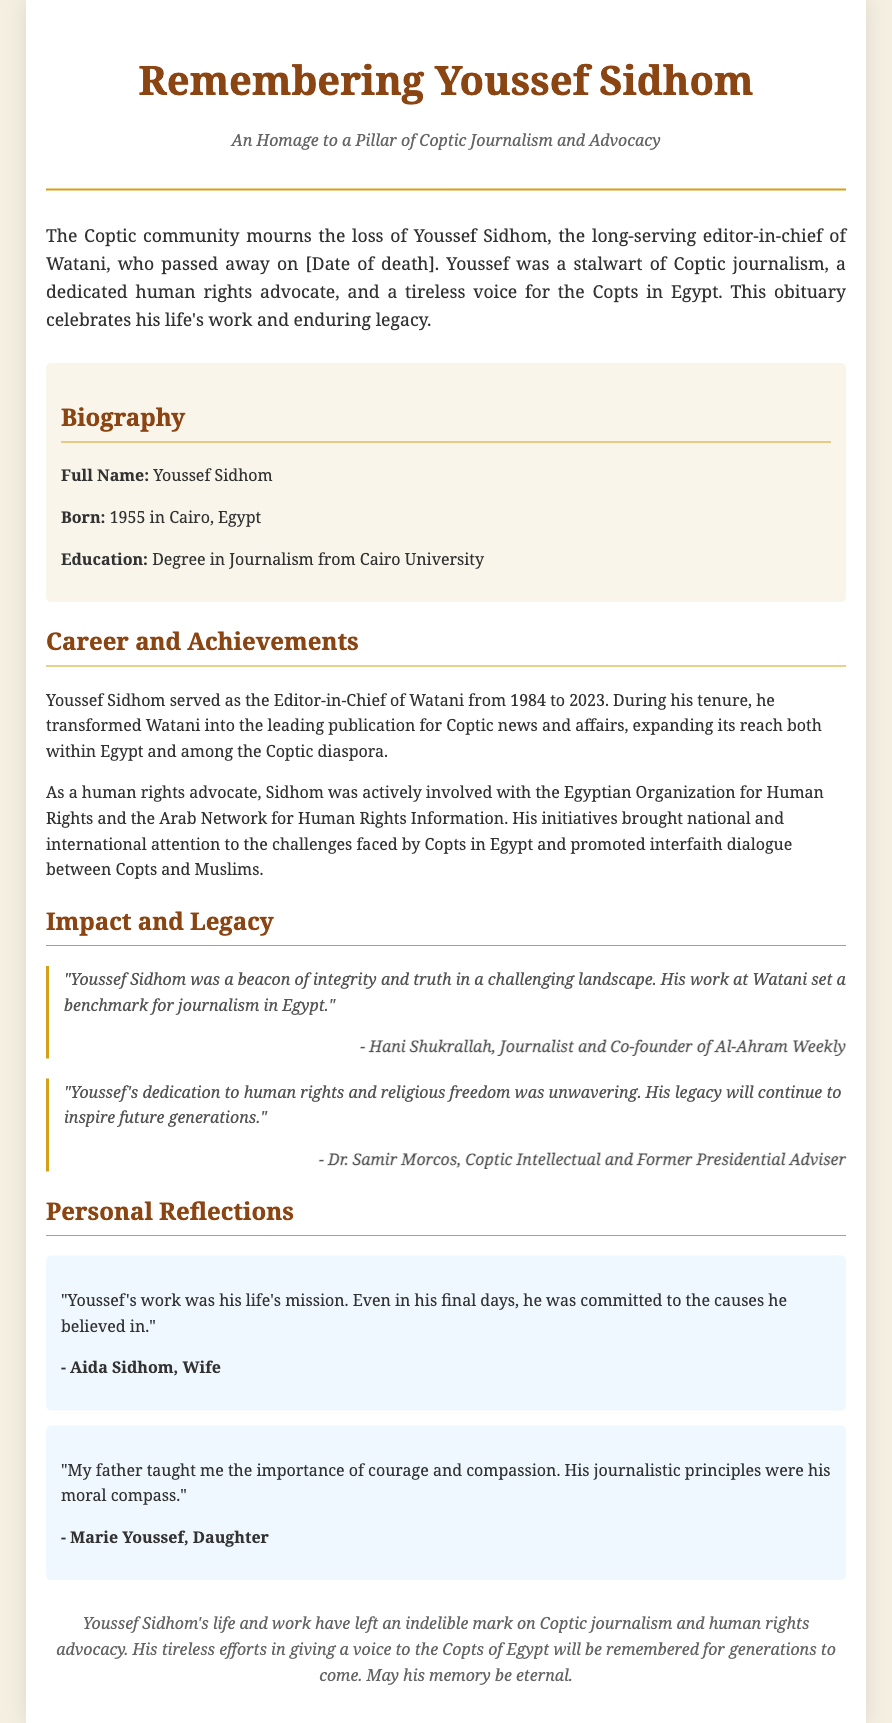What is the full name of the individual being remembered? The full name of the individual is stated explicitly in the document.
Answer: Youssef Sidhom In which year was Youssef Sidhom born? The document provides the year of birth for Youssef Sidhom in the biography section.
Answer: 1955 Which publication did Youssef Sidhom serve as editor-in-chief? The document clearly mentions the name of the publication associated with Youssef Sidhom.
Answer: Watani For how many years did Youssef Sidhom serve as the editor-in-chief of Watani? The document specifies the years he served as the editor-in-chief, allowing for a simple calculation.
Answer: 39 years What organization was Youssef Sidhom associated with for human rights advocacy? The document mentions specific organizations that Youssef Sidhom was involved with during his advocacy.
Answer: Egyptian Organization for Human Rights Who described Youssef Sidhom as a "beacon of integrity and truth"? The document mentions a specific individual who made this statement about Youssef Sidhom.
Answer: Hani Shukrallah What was the emphasis of Youssef Sidhom's work throughout his career? The document outlines key themes regarding Youssef Sidhom's work impact and legacy.
Answer: Human rights What relationship did Aida Sidhom have with Youssef Sidhom? The document specifies the familial relationship of Aida Sidhom to Youssef Sidhom.
Answer: Wife What year did Youssef Sidhom pass away? The document mentions a placeholder for the date of death, but we can identify that it was a specific year.
Answer: 2023 What is the main theme of the obituary? The document indicates the overarching theme and focus of the obituary.
Answer: Tribute to Youssef Sidhom 